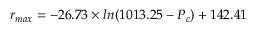<formula> <loc_0><loc_0><loc_500><loc_500>r _ { \max } = - 2 6 . 7 3 \times \ln ( 1 0 1 3 . 2 5 - P _ { c } ) + 1 4 2 . 4 1</formula> 